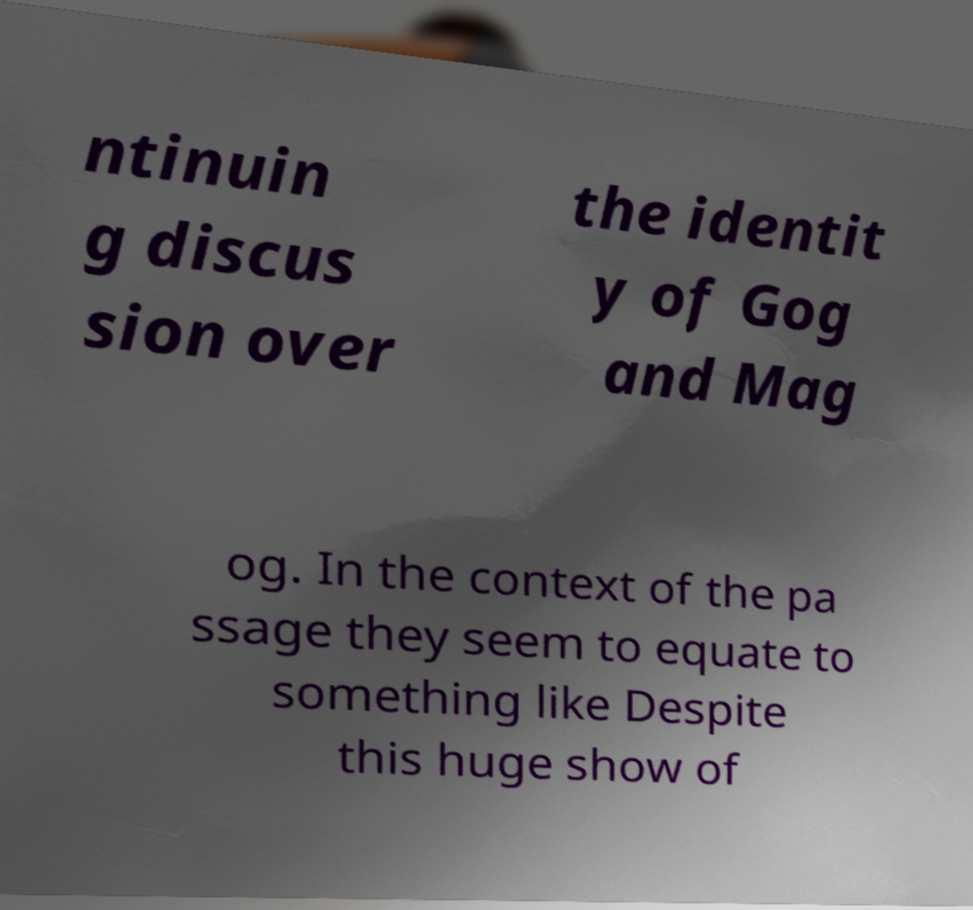Could you extract and type out the text from this image? ntinuin g discus sion over the identit y of Gog and Mag og. In the context of the pa ssage they seem to equate to something like Despite this huge show of 